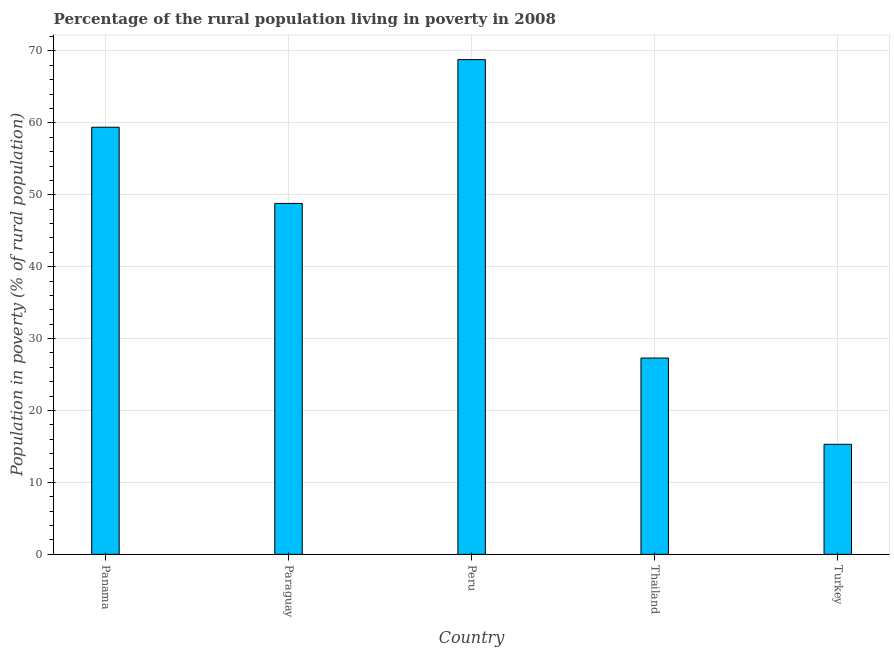What is the title of the graph?
Give a very brief answer. Percentage of the rural population living in poverty in 2008. What is the label or title of the X-axis?
Offer a very short reply. Country. What is the label or title of the Y-axis?
Provide a succinct answer. Population in poverty (% of rural population). What is the percentage of rural population living below poverty line in Paraguay?
Your answer should be very brief. 48.8. Across all countries, what is the maximum percentage of rural population living below poverty line?
Your answer should be compact. 68.8. In which country was the percentage of rural population living below poverty line maximum?
Offer a terse response. Peru. In which country was the percentage of rural population living below poverty line minimum?
Your answer should be very brief. Turkey. What is the sum of the percentage of rural population living below poverty line?
Offer a very short reply. 219.6. What is the difference between the percentage of rural population living below poverty line in Peru and Thailand?
Your answer should be compact. 41.5. What is the average percentage of rural population living below poverty line per country?
Provide a short and direct response. 43.92. What is the median percentage of rural population living below poverty line?
Make the answer very short. 48.8. What is the ratio of the percentage of rural population living below poverty line in Paraguay to that in Thailand?
Offer a very short reply. 1.79. Is the sum of the percentage of rural population living below poverty line in Panama and Peru greater than the maximum percentage of rural population living below poverty line across all countries?
Your answer should be compact. Yes. What is the difference between the highest and the lowest percentage of rural population living below poverty line?
Offer a terse response. 53.5. Are all the bars in the graph horizontal?
Provide a succinct answer. No. Are the values on the major ticks of Y-axis written in scientific E-notation?
Make the answer very short. No. What is the Population in poverty (% of rural population) of Panama?
Your response must be concise. 59.4. What is the Population in poverty (% of rural population) in Paraguay?
Ensure brevity in your answer.  48.8. What is the Population in poverty (% of rural population) in Peru?
Provide a succinct answer. 68.8. What is the Population in poverty (% of rural population) in Thailand?
Your answer should be compact. 27.3. What is the Population in poverty (% of rural population) in Turkey?
Provide a short and direct response. 15.3. What is the difference between the Population in poverty (% of rural population) in Panama and Peru?
Your response must be concise. -9.4. What is the difference between the Population in poverty (% of rural population) in Panama and Thailand?
Your answer should be compact. 32.1. What is the difference between the Population in poverty (% of rural population) in Panama and Turkey?
Make the answer very short. 44.1. What is the difference between the Population in poverty (% of rural population) in Paraguay and Turkey?
Give a very brief answer. 33.5. What is the difference between the Population in poverty (% of rural population) in Peru and Thailand?
Your answer should be compact. 41.5. What is the difference between the Population in poverty (% of rural population) in Peru and Turkey?
Your response must be concise. 53.5. What is the difference between the Population in poverty (% of rural population) in Thailand and Turkey?
Provide a short and direct response. 12. What is the ratio of the Population in poverty (% of rural population) in Panama to that in Paraguay?
Your answer should be compact. 1.22. What is the ratio of the Population in poverty (% of rural population) in Panama to that in Peru?
Your answer should be compact. 0.86. What is the ratio of the Population in poverty (% of rural population) in Panama to that in Thailand?
Offer a very short reply. 2.18. What is the ratio of the Population in poverty (% of rural population) in Panama to that in Turkey?
Provide a short and direct response. 3.88. What is the ratio of the Population in poverty (% of rural population) in Paraguay to that in Peru?
Your response must be concise. 0.71. What is the ratio of the Population in poverty (% of rural population) in Paraguay to that in Thailand?
Your answer should be compact. 1.79. What is the ratio of the Population in poverty (% of rural population) in Paraguay to that in Turkey?
Ensure brevity in your answer.  3.19. What is the ratio of the Population in poverty (% of rural population) in Peru to that in Thailand?
Provide a short and direct response. 2.52. What is the ratio of the Population in poverty (% of rural population) in Peru to that in Turkey?
Keep it short and to the point. 4.5. What is the ratio of the Population in poverty (% of rural population) in Thailand to that in Turkey?
Make the answer very short. 1.78. 